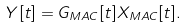Convert formula to latex. <formula><loc_0><loc_0><loc_500><loc_500>Y [ t ] = G _ { M A C } [ t ] X _ { M A C } [ t ] .</formula> 